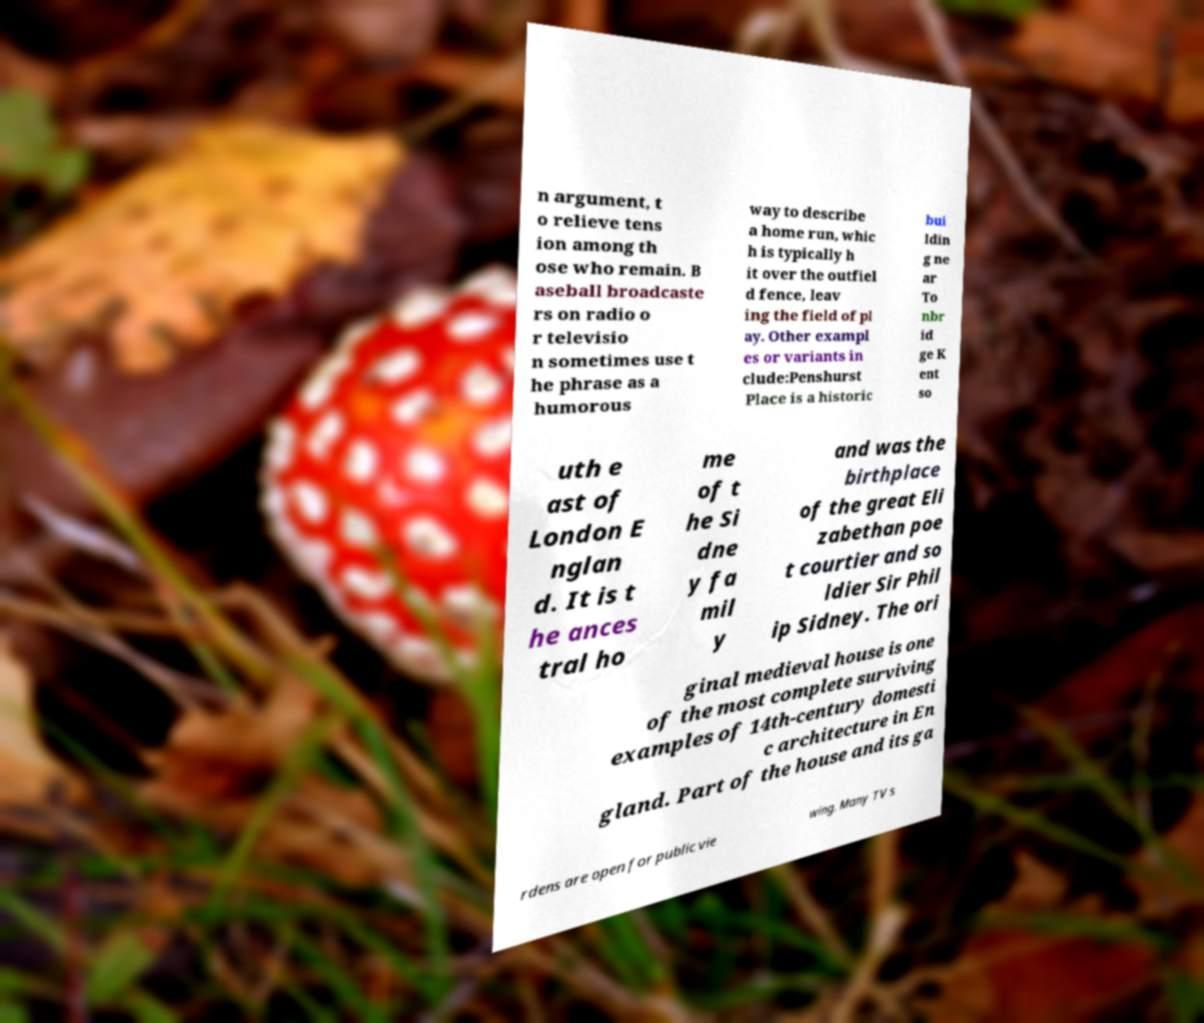Can you read and provide the text displayed in the image?This photo seems to have some interesting text. Can you extract and type it out for me? n argument, t o relieve tens ion among th ose who remain. B aseball broadcaste rs on radio o r televisio n sometimes use t he phrase as a humorous way to describe a home run, whic h is typically h it over the outfiel d fence, leav ing the field of pl ay. Other exampl es or variants in clude:Penshurst Place is a historic bui ldin g ne ar To nbr id ge K ent so uth e ast of London E nglan d. It is t he ances tral ho me of t he Si dne y fa mil y and was the birthplace of the great Eli zabethan poe t courtier and so ldier Sir Phil ip Sidney. The ori ginal medieval house is one of the most complete surviving examples of 14th-century domesti c architecture in En gland. Part of the house and its ga rdens are open for public vie wing. Many TV s 